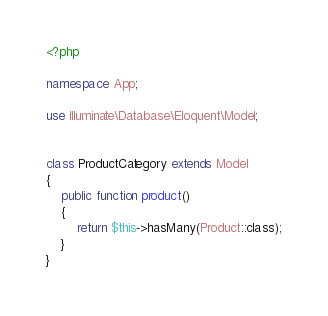<code> <loc_0><loc_0><loc_500><loc_500><_PHP_><?php

namespace App;

use Illuminate\Database\Eloquent\Model;


class ProductCategory extends Model
{
    public function product() 
    {
    	return $this->hasMany(Product::class);
    }
}
</code> 